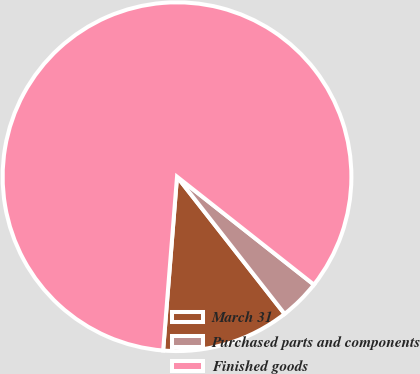Convert chart. <chart><loc_0><loc_0><loc_500><loc_500><pie_chart><fcel>March 31<fcel>Purchased parts and components<fcel>Finished goods<nl><fcel>11.85%<fcel>3.79%<fcel>84.36%<nl></chart> 